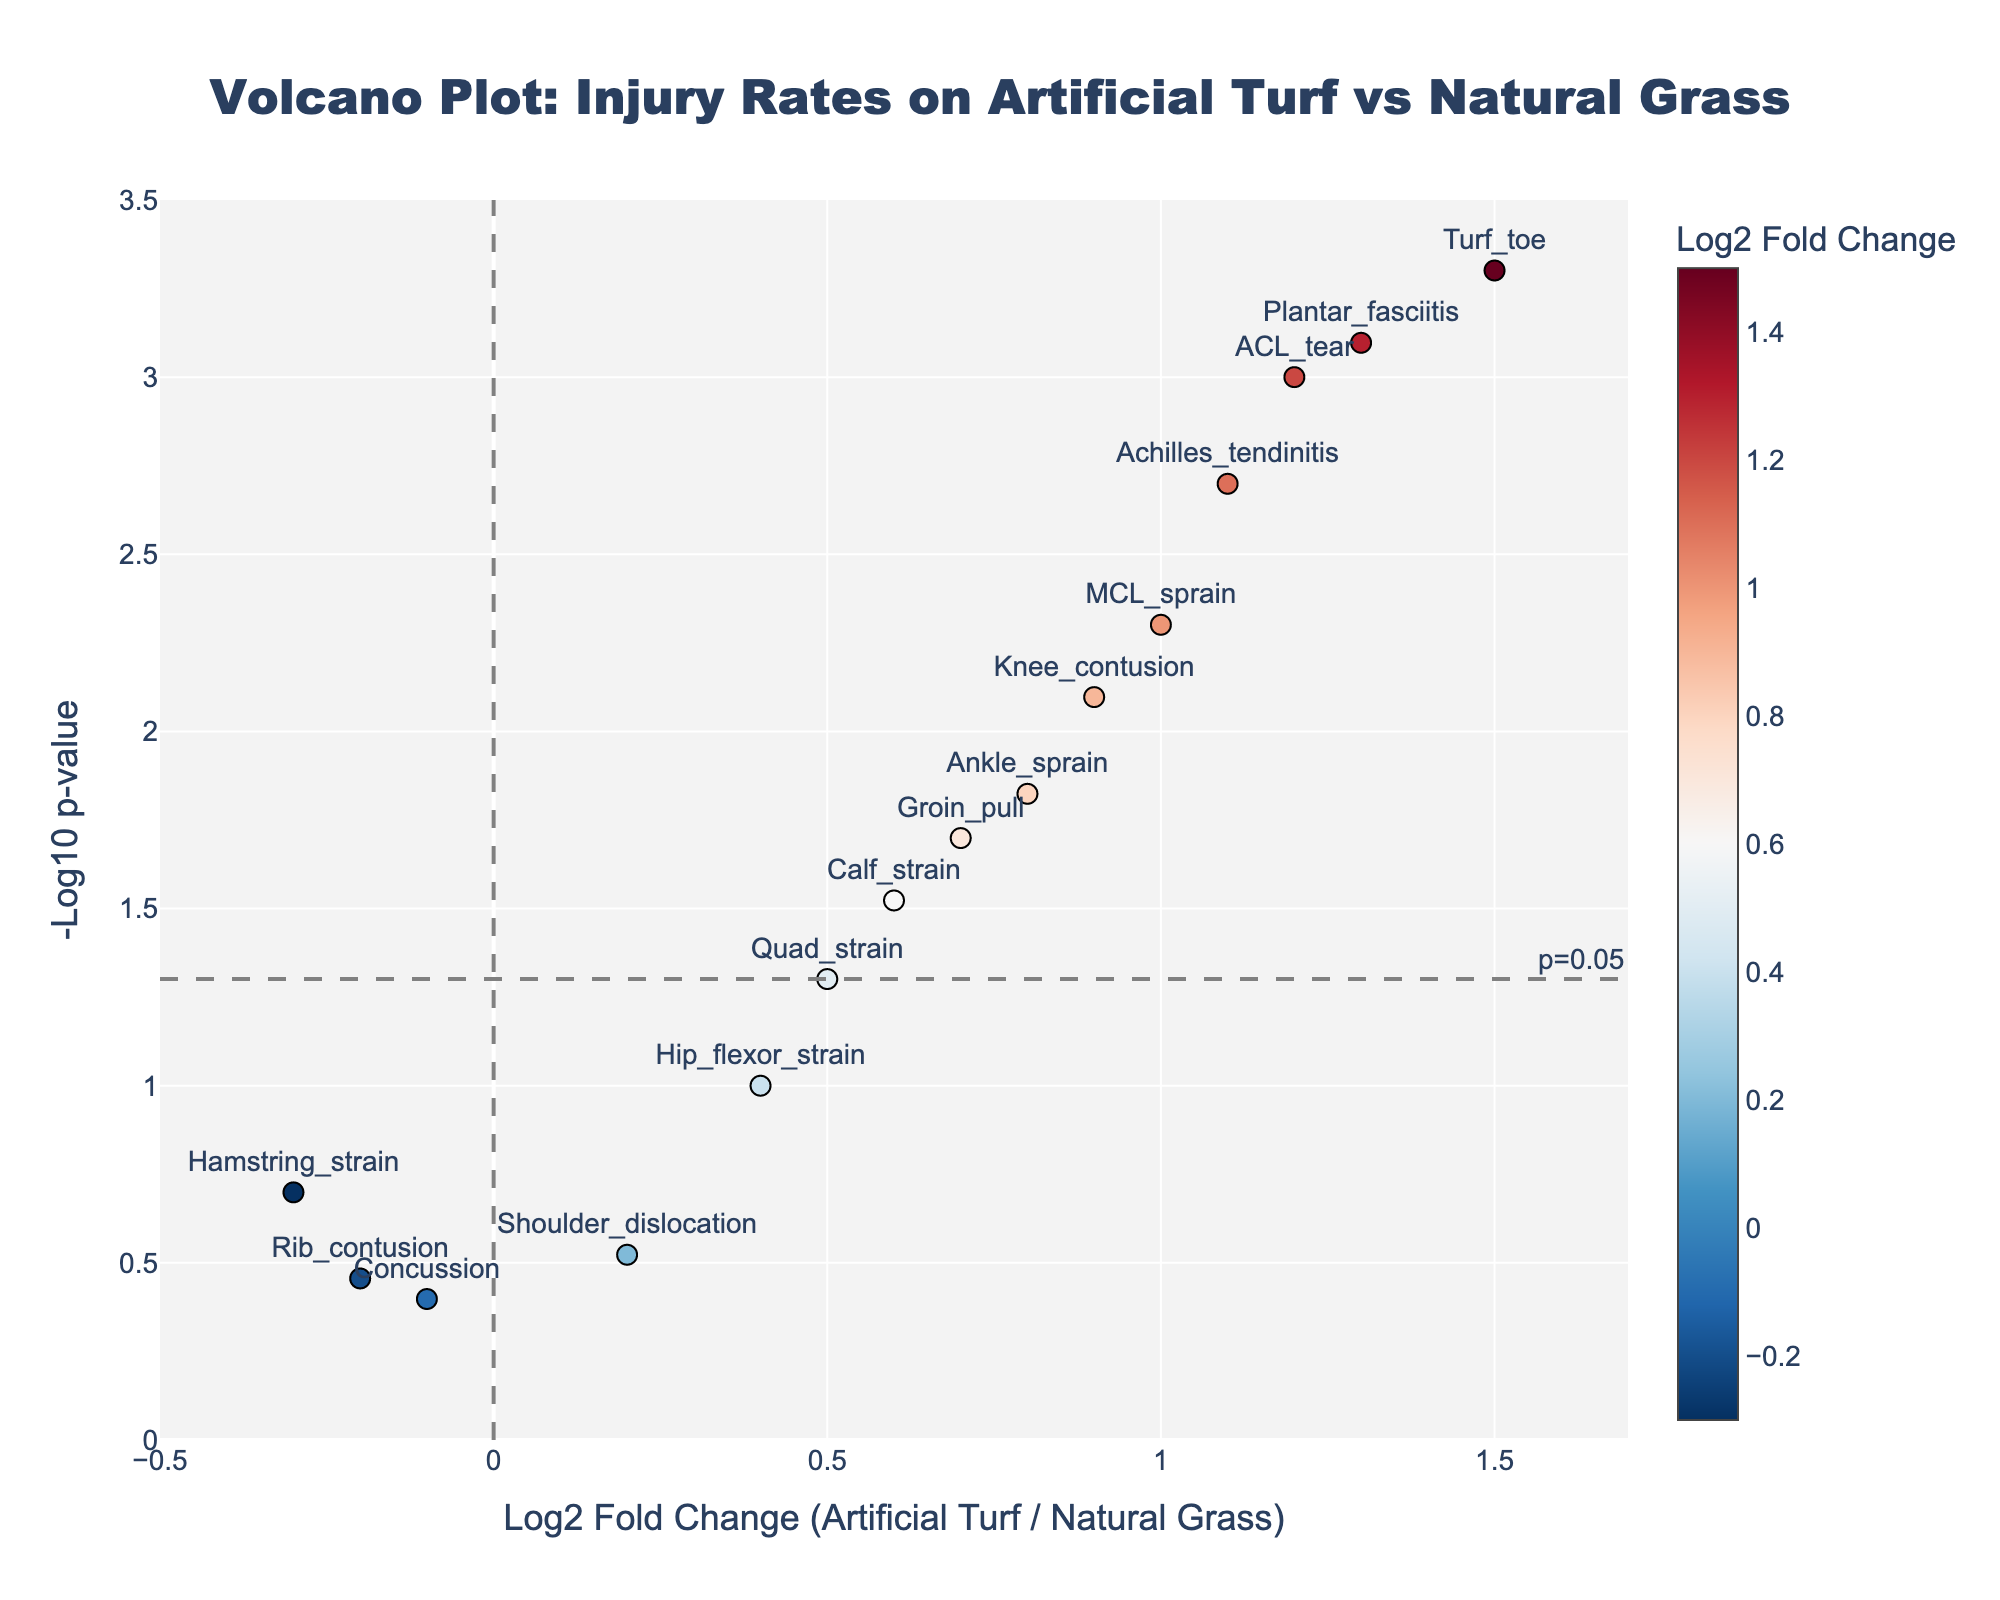How many injury types are displayed in the volcano plot? Count the number of data points (injury types) labeled on the plot.
Answer: 15 What does the x-axis represent in the volcano plot? The x-axis shows the log2 fold change of injury rates between artificial turf and natural grass.
Answer: Log2 Fold Change What injury type has the highest log2 fold change? Identify the data point with the largest x-value on the plot.
Answer: Turf toe What does the y-axis represent in the volcano plot? The y-axis displays the negative logarithm base 10 of the p-value (-log10 p-value).
Answer: -Log10 p-value Which injury type is closest to the vertical threshold line? Find the data point with the smallest positive or negative x-value near x = 0.
Answer: Concussion How many injury types are statistically significant with a p-value less than 0.05? Count the data points above the horizontal threshold line at y = -log10(0.05) ≈ 1.3.
Answer: 11 Of the statistically significant injury types, which one has the lowest log2 fold change? Among the points higher than the horizontal line at y ≈ 1.3, identify the one with the smallest x-value.
Answer: MCL sprain Is there any injury type with a negative log2 fold change and a statistically significant p-value? Check if any points left of the vertical line at x = 0 are above the horizontal line at y ≈ 1.3.
Answer: No Which injury types have a log2 fold change between 0.5 and 1.0 and are statistically significant? Identify the points within the x-range (0.5, 1.0) that are above the horizontal line at y ≈ 1.3.
Answer: Knee contusion, MCL sprain What inference can you make based on the position of "Hamstring strain" and its p-value? Locate "Hamstring strain" on the plot to determine if it is statistically significant (if y < 1.3) and its relative risk (if x > 0 or x < 0).
Answer: Hamstring strain has a low, non-significant change in injury rate and a p-value above 0.05 